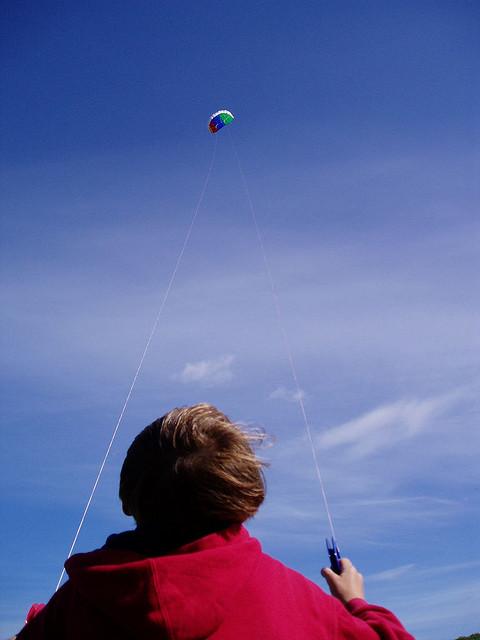Is he casting a shadow?
Quick response, please. No. Is it windy?
Give a very brief answer. Yes. What color is the person's hair?
Give a very brief answer. Brown. How many strings are attached to the kite?
Concise answer only. 2. 